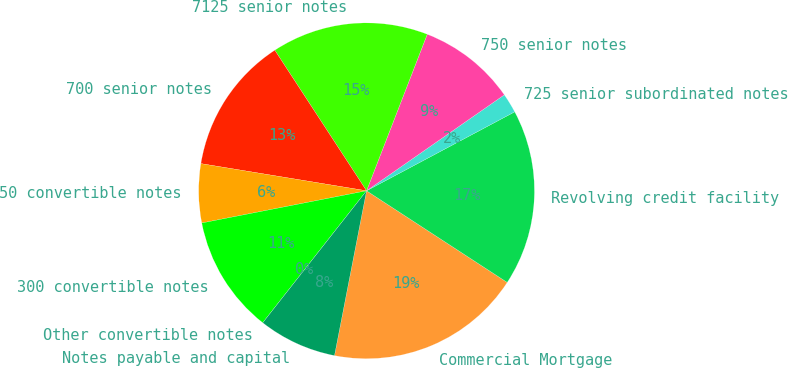Convert chart to OTSL. <chart><loc_0><loc_0><loc_500><loc_500><pie_chart><fcel>Commercial Mortgage<fcel>Revolving credit facility<fcel>725 senior subordinated notes<fcel>750 senior notes<fcel>7125 senior notes<fcel>700 senior notes<fcel>50 convertible notes<fcel>300 convertible notes<fcel>Other convertible notes<fcel>Notes payable and capital<nl><fcel>18.87%<fcel>16.98%<fcel>1.89%<fcel>9.43%<fcel>15.09%<fcel>13.21%<fcel>5.66%<fcel>11.32%<fcel>0.0%<fcel>7.55%<nl></chart> 